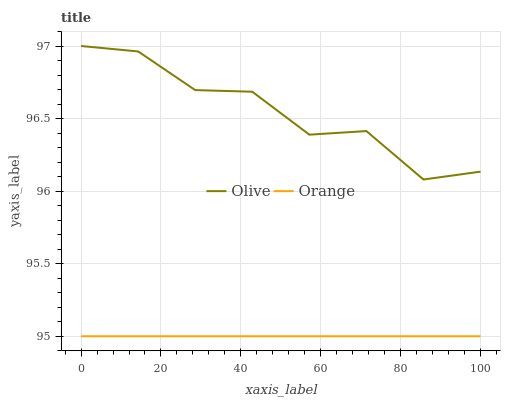Does Orange have the minimum area under the curve?
Answer yes or no. Yes. Does Olive have the maximum area under the curve?
Answer yes or no. Yes. Does Orange have the maximum area under the curve?
Answer yes or no. No. Is Orange the smoothest?
Answer yes or no. Yes. Is Olive the roughest?
Answer yes or no. Yes. Is Orange the roughest?
Answer yes or no. No. Does Orange have the lowest value?
Answer yes or no. Yes. Does Olive have the highest value?
Answer yes or no. Yes. Does Orange have the highest value?
Answer yes or no. No. Is Orange less than Olive?
Answer yes or no. Yes. Is Olive greater than Orange?
Answer yes or no. Yes. Does Orange intersect Olive?
Answer yes or no. No. 